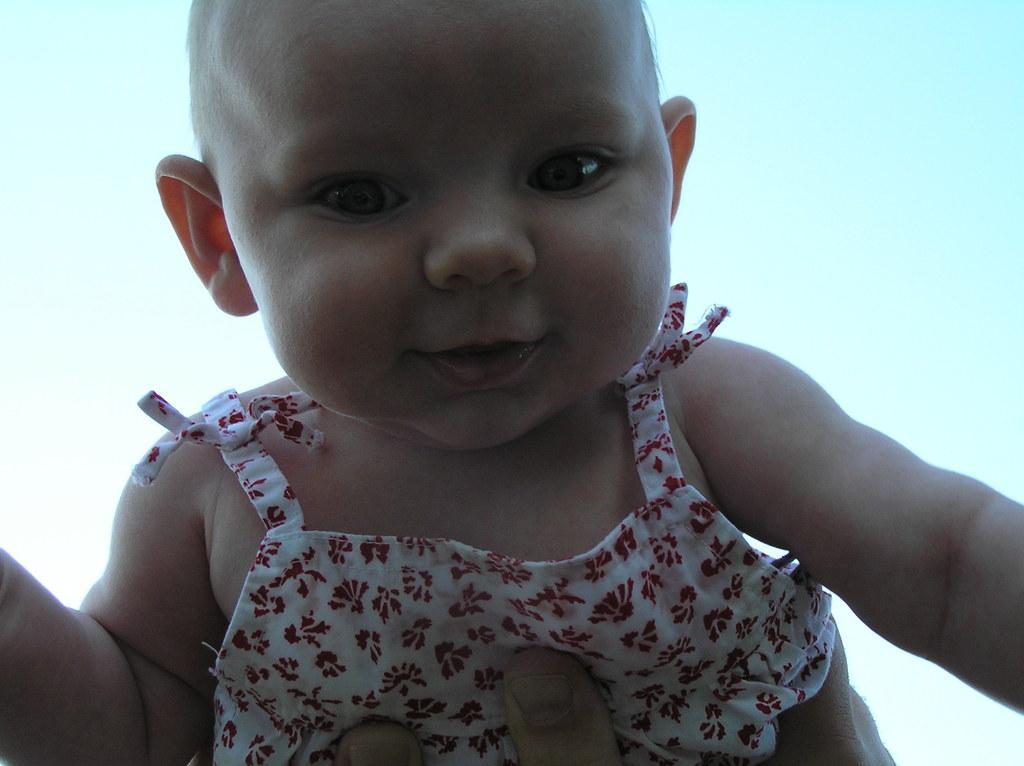Can you describe this image briefly? In this image, we can see a baby is seeing and smiling. At the bottom, we can see human fingers. Background there is a sky. 